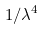<formula> <loc_0><loc_0><loc_500><loc_500>1 / \lambda ^ { 4 }</formula> 